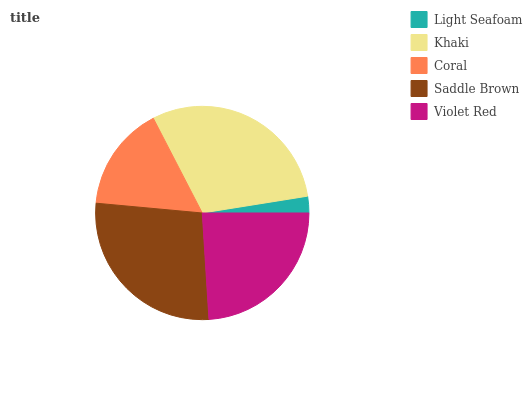Is Light Seafoam the minimum?
Answer yes or no. Yes. Is Khaki the maximum?
Answer yes or no. Yes. Is Coral the minimum?
Answer yes or no. No. Is Coral the maximum?
Answer yes or no. No. Is Khaki greater than Coral?
Answer yes or no. Yes. Is Coral less than Khaki?
Answer yes or no. Yes. Is Coral greater than Khaki?
Answer yes or no. No. Is Khaki less than Coral?
Answer yes or no. No. Is Violet Red the high median?
Answer yes or no. Yes. Is Violet Red the low median?
Answer yes or no. Yes. Is Saddle Brown the high median?
Answer yes or no. No. Is Coral the low median?
Answer yes or no. No. 